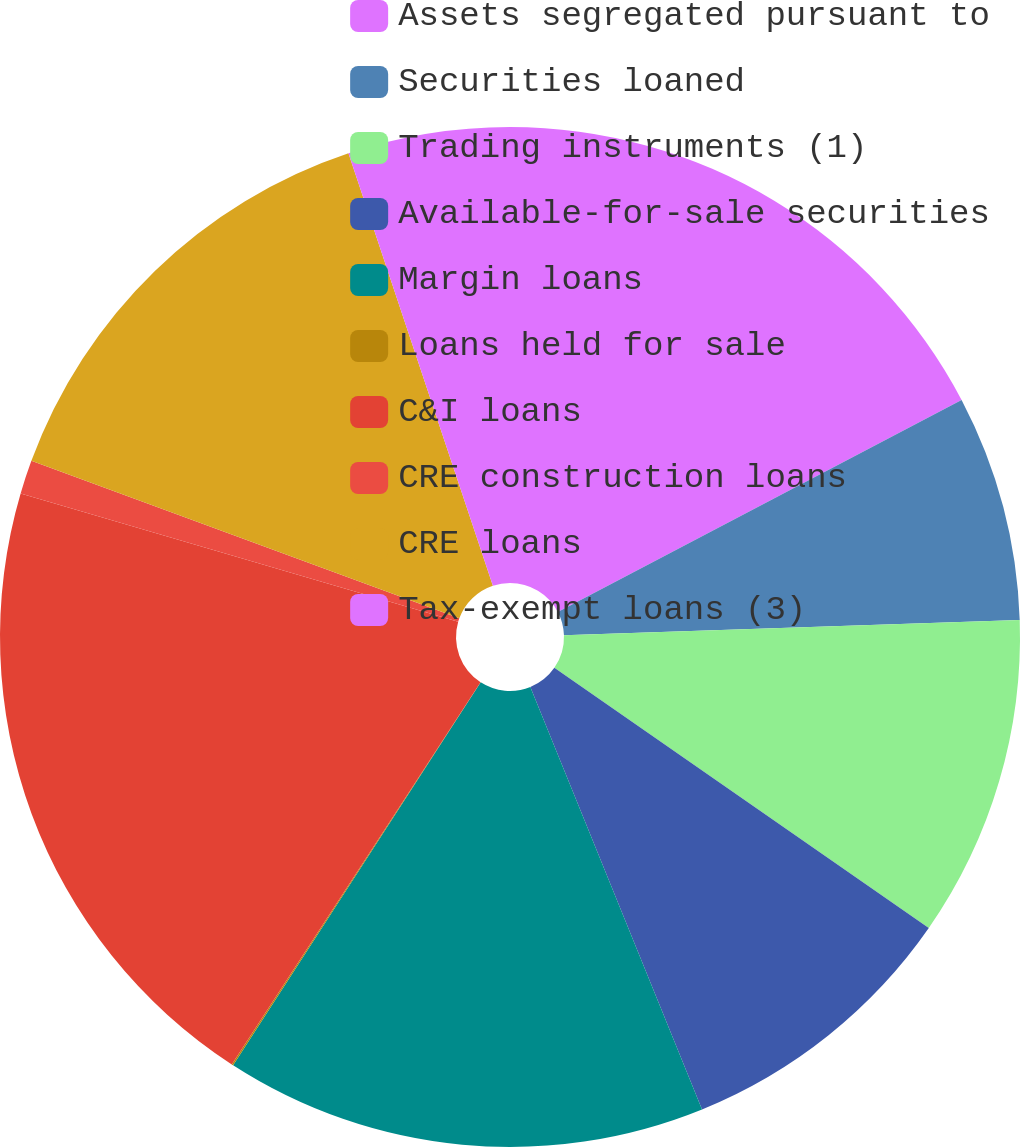<chart> <loc_0><loc_0><loc_500><loc_500><pie_chart><fcel>Assets segregated pursuant to<fcel>Securities loaned<fcel>Trading instruments (1)<fcel>Available-for-sale securities<fcel>Margin loans<fcel>Loans held for sale<fcel>C&I loans<fcel>CRE construction loans<fcel>CRE loans<fcel>Tax-exempt loans (3)<nl><fcel>17.31%<fcel>7.16%<fcel>10.2%<fcel>9.19%<fcel>15.28%<fcel>0.05%<fcel>20.36%<fcel>1.07%<fcel>14.26%<fcel>5.13%<nl></chart> 